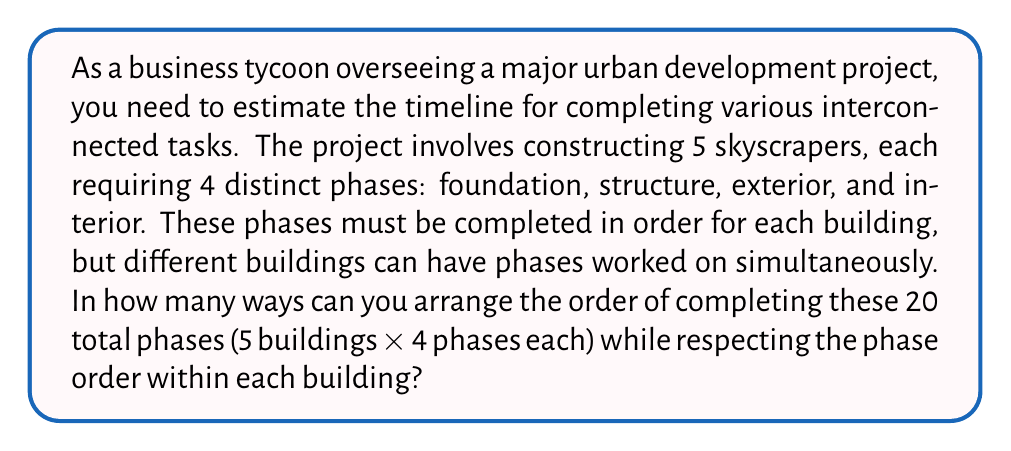Show me your answer to this math problem. Let's approach this step-by-step:

1) First, we need to recognize that this is a problem of permutations with restrictions. We have 20 total phases, but they're not entirely free to be arranged in any order.

2) For each building, the 4 phases must be in a specific order. This means we can think of each building's set of phases as a single unit.

3) So, we essentially have 5 units (buildings) to arrange, and within each unit, we have 4 phases that are fixed in order.

4) This scenario is perfectly suited for the concept of Permutations with Repetition.

5) The formula for Permutations with Repetition is:

   $$\frac{n!}{n_1! \cdot n_2! \cdot ... \cdot n_k!}$$

   Where $n$ is the total number of items, and $n_1, n_2, ..., n_k$ are the numbers of each type of item.

6) In our case:
   $n = 20$ (total phases)
   $n_1 = n_2 = n_3 = n_4 = n_5 = 4$ (phases per building)

7) Plugging into the formula:

   $$\frac{20!}{4! \cdot 4! \cdot 4! \cdot 4! \cdot 4!}$$

8) Calculating this:
   $20! = 2.43290201 \times 10^{18}$
   $(4!)^5 = (24)^5 = 7,962,624$

   $$\frac{2.43290201 \times 10^{18}}{7,962,624} = 305,540,235,000$$

Therefore, there are 305,540,235,000 ways to arrange the order of completing these phases.
Answer: 305,540,235,000 